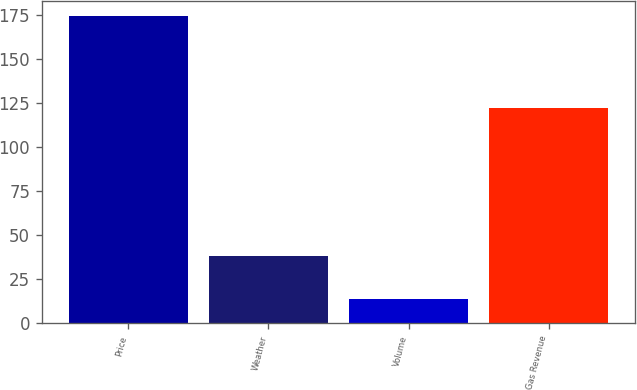<chart> <loc_0><loc_0><loc_500><loc_500><bar_chart><fcel>Price<fcel>Weather<fcel>Volume<fcel>Gas Revenue<nl><fcel>174<fcel>38<fcel>14<fcel>122<nl></chart> 